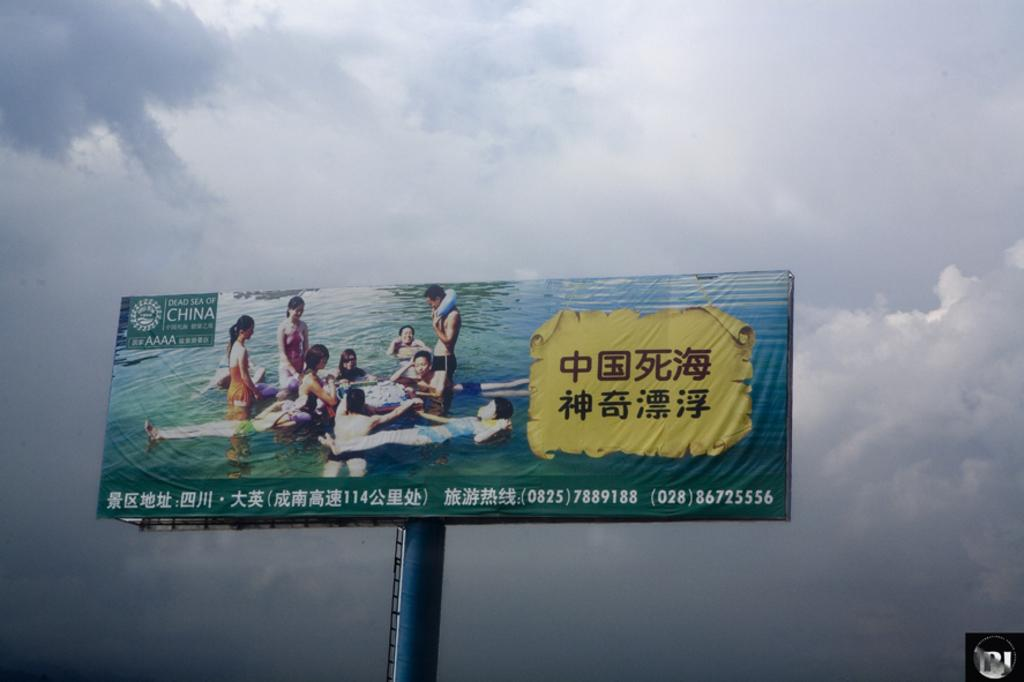<image>
Render a clear and concise summary of the photo. A high billboard for the Dead Sea of China. 